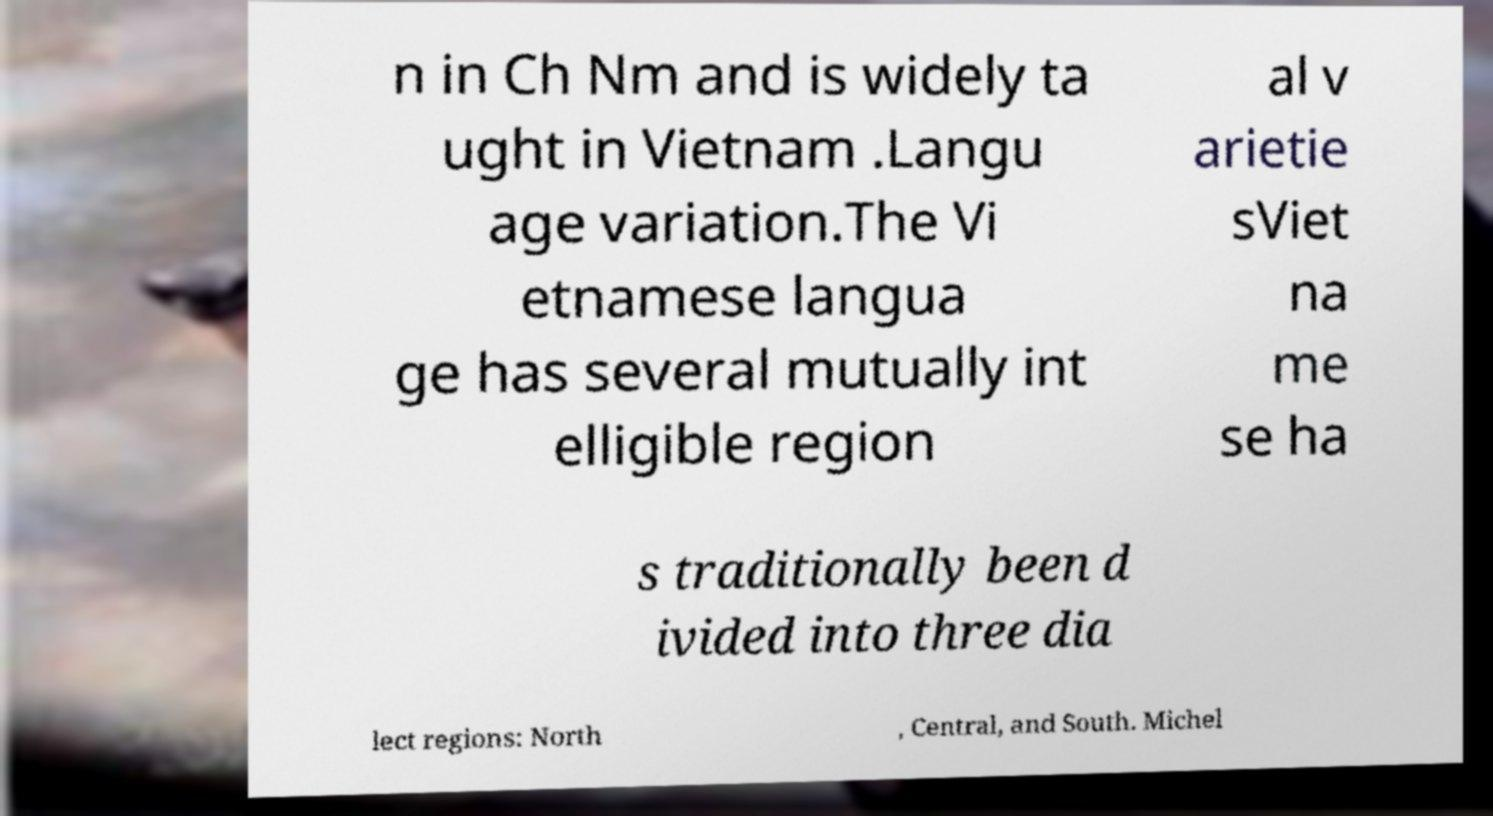Could you assist in decoding the text presented in this image and type it out clearly? n in Ch Nm and is widely ta ught in Vietnam .Langu age variation.The Vi etnamese langua ge has several mutually int elligible region al v arietie sViet na me se ha s traditionally been d ivided into three dia lect regions: North , Central, and South. Michel 